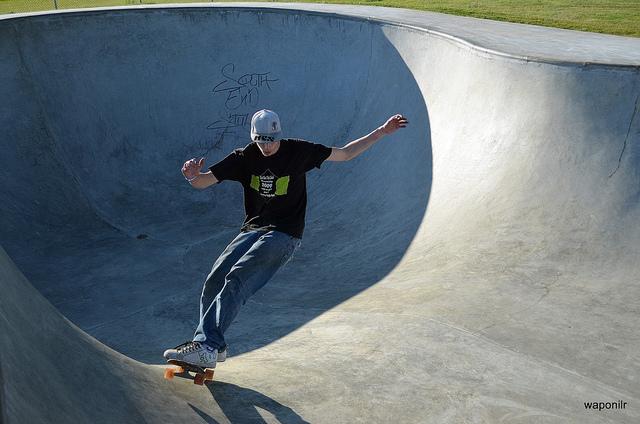Can the man see his shadow?
Keep it brief. Yes. Are they rollerblading?
Quick response, please. No. What is the man doing?
Short answer required. Skateboarding. What is the logo on the person's tee shirt?
Short answer required. Unknown. What is on the boarders right wrist?
Keep it brief. Watch. 